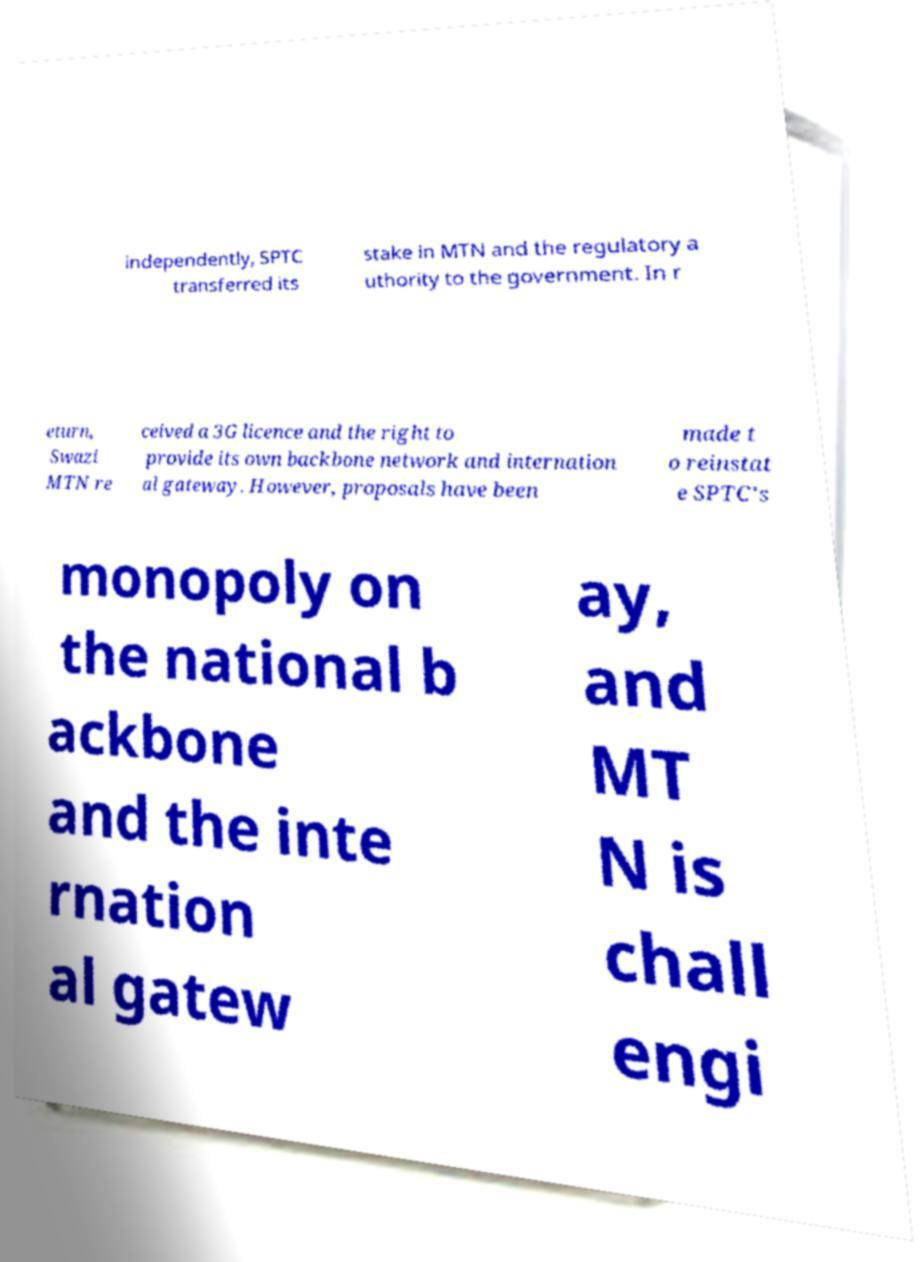Can you read and provide the text displayed in the image?This photo seems to have some interesting text. Can you extract and type it out for me? independently, SPTC transferred its stake in MTN and the regulatory a uthority to the government. In r eturn, Swazi MTN re ceived a 3G licence and the right to provide its own backbone network and internation al gateway. However, proposals have been made t o reinstat e SPTC's monopoly on the national b ackbone and the inte rnation al gatew ay, and MT N is chall engi 